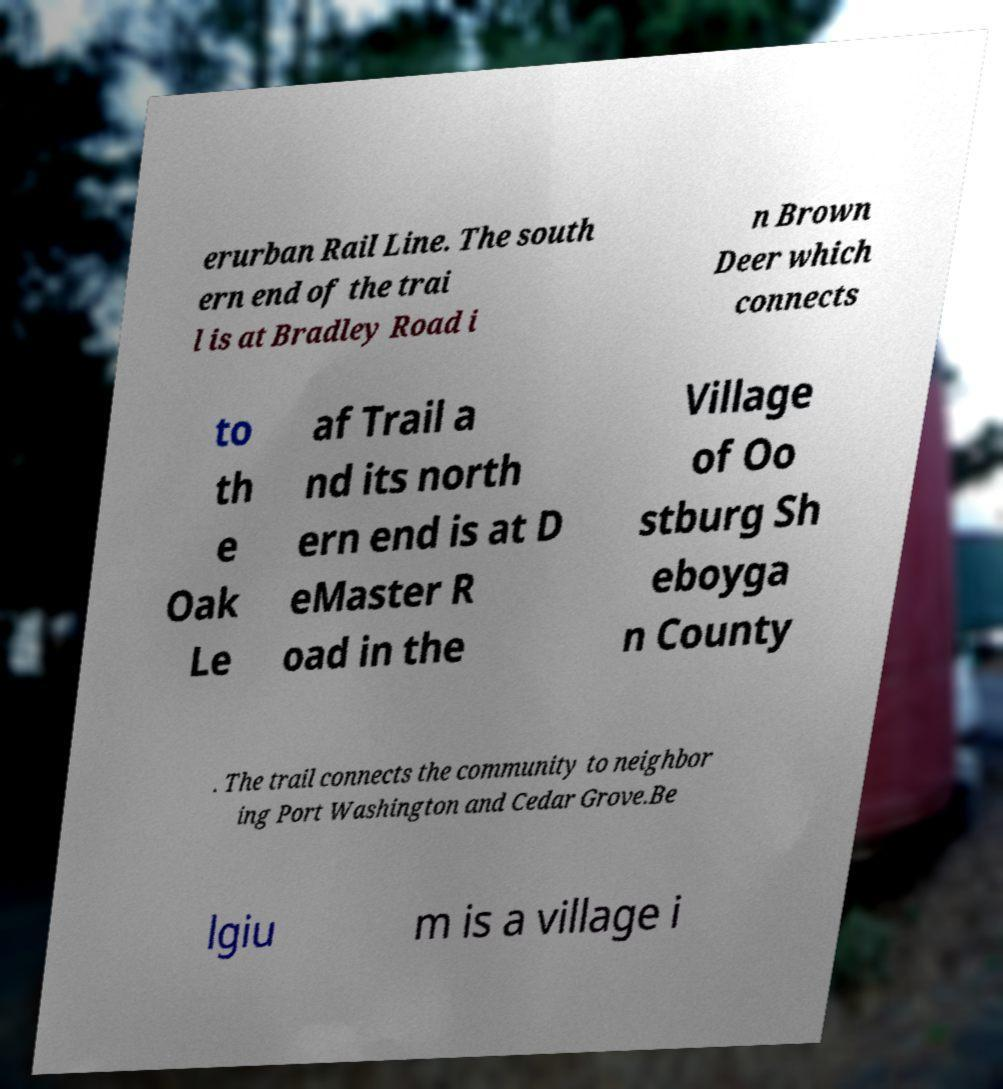For documentation purposes, I need the text within this image transcribed. Could you provide that? erurban Rail Line. The south ern end of the trai l is at Bradley Road i n Brown Deer which connects to th e Oak Le af Trail a nd its north ern end is at D eMaster R oad in the Village of Oo stburg Sh eboyga n County . The trail connects the community to neighbor ing Port Washington and Cedar Grove.Be lgiu m is a village i 